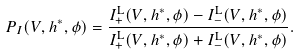Convert formula to latex. <formula><loc_0><loc_0><loc_500><loc_500>P _ { I } ( V , h ^ { * } , \phi ) = \frac { I _ { + } ^ { \text {L} } ( V , h ^ { * } , \phi ) - I _ { - } ^ { \text {L} } ( V , h ^ { * } , \phi ) } { I _ { + } ^ { \text {L} } ( V , h ^ { * } , \phi ) + I _ { - } ^ { \text {L} } ( V , h ^ { * } , \phi ) } .</formula> 